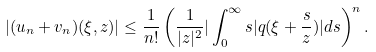<formula> <loc_0><loc_0><loc_500><loc_500>| ( u _ { n } + v _ { n } ) ( \xi , z ) | \leq \frac { 1 } { n ! } \left ( \frac { 1 } { | z | ^ { 2 } } | \int _ { 0 } ^ { \infty } s | q ( \xi + \frac { s } { z } ) | d s \right ) ^ { n } .</formula> 